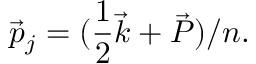Convert formula to latex. <formula><loc_0><loc_0><loc_500><loc_500>\vec { p } _ { j } = ( { \frac { 1 } { 2 } } \vec { k } + \vec { P } ) / n .</formula> 